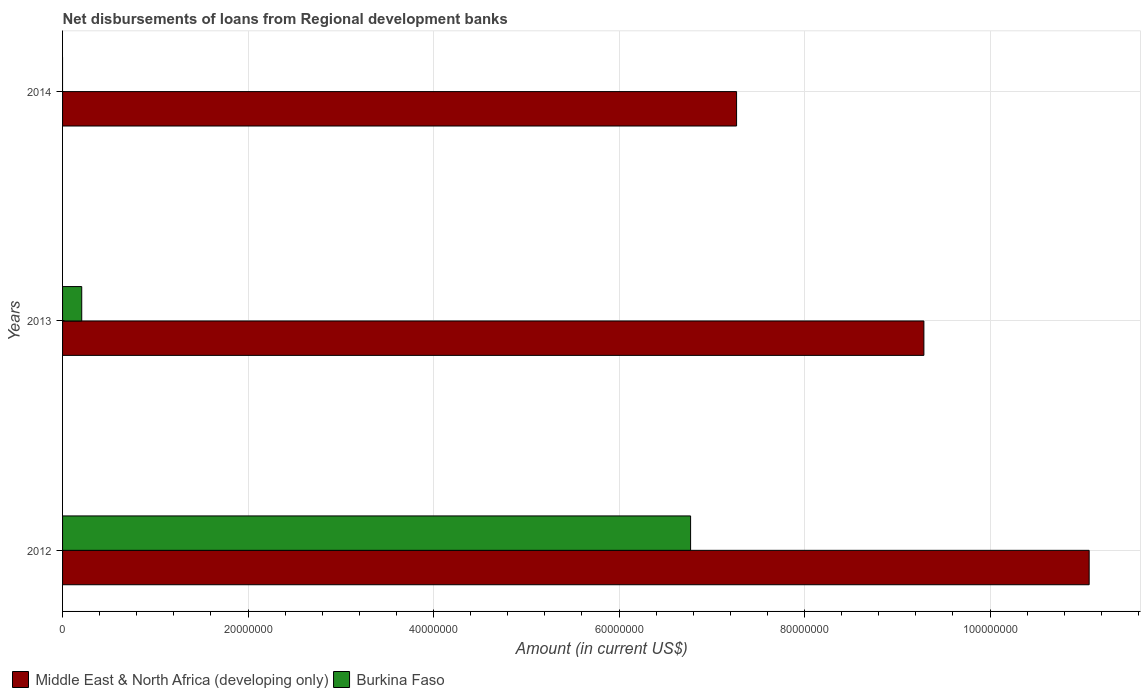How many different coloured bars are there?
Your response must be concise. 2. Are the number of bars per tick equal to the number of legend labels?
Keep it short and to the point. No. Are the number of bars on each tick of the Y-axis equal?
Ensure brevity in your answer.  No. How many bars are there on the 3rd tick from the top?
Offer a terse response. 2. How many bars are there on the 1st tick from the bottom?
Your answer should be compact. 2. What is the amount of disbursements of loans from regional development banks in Middle East & North Africa (developing only) in 2012?
Provide a succinct answer. 1.11e+08. Across all years, what is the maximum amount of disbursements of loans from regional development banks in Middle East & North Africa (developing only)?
Give a very brief answer. 1.11e+08. Across all years, what is the minimum amount of disbursements of loans from regional development banks in Middle East & North Africa (developing only)?
Your answer should be very brief. 7.27e+07. In which year was the amount of disbursements of loans from regional development banks in Middle East & North Africa (developing only) maximum?
Your response must be concise. 2012. What is the total amount of disbursements of loans from regional development banks in Burkina Faso in the graph?
Keep it short and to the point. 6.98e+07. What is the difference between the amount of disbursements of loans from regional development banks in Burkina Faso in 2012 and that in 2013?
Ensure brevity in your answer.  6.56e+07. What is the difference between the amount of disbursements of loans from regional development banks in Middle East & North Africa (developing only) in 2014 and the amount of disbursements of loans from regional development banks in Burkina Faso in 2012?
Make the answer very short. 4.96e+06. What is the average amount of disbursements of loans from regional development banks in Burkina Faso per year?
Make the answer very short. 2.33e+07. In the year 2012, what is the difference between the amount of disbursements of loans from regional development banks in Middle East & North Africa (developing only) and amount of disbursements of loans from regional development banks in Burkina Faso?
Offer a very short reply. 4.30e+07. In how many years, is the amount of disbursements of loans from regional development banks in Middle East & North Africa (developing only) greater than 56000000 US$?
Offer a terse response. 3. What is the ratio of the amount of disbursements of loans from regional development banks in Middle East & North Africa (developing only) in 2013 to that in 2014?
Keep it short and to the point. 1.28. Is the difference between the amount of disbursements of loans from regional development banks in Middle East & North Africa (developing only) in 2012 and 2013 greater than the difference between the amount of disbursements of loans from regional development banks in Burkina Faso in 2012 and 2013?
Make the answer very short. No. What is the difference between the highest and the second highest amount of disbursements of loans from regional development banks in Middle East & North Africa (developing only)?
Make the answer very short. 1.78e+07. What is the difference between the highest and the lowest amount of disbursements of loans from regional development banks in Middle East & North Africa (developing only)?
Keep it short and to the point. 3.80e+07. Are all the bars in the graph horizontal?
Provide a succinct answer. Yes. How many years are there in the graph?
Your answer should be compact. 3. What is the difference between two consecutive major ticks on the X-axis?
Provide a succinct answer. 2.00e+07. Are the values on the major ticks of X-axis written in scientific E-notation?
Offer a terse response. No. Does the graph contain any zero values?
Offer a terse response. Yes. Where does the legend appear in the graph?
Keep it short and to the point. Bottom left. What is the title of the graph?
Your response must be concise. Net disbursements of loans from Regional development banks. Does "Togo" appear as one of the legend labels in the graph?
Offer a very short reply. No. What is the label or title of the X-axis?
Ensure brevity in your answer.  Amount (in current US$). What is the Amount (in current US$) of Middle East & North Africa (developing only) in 2012?
Provide a short and direct response. 1.11e+08. What is the Amount (in current US$) in Burkina Faso in 2012?
Provide a short and direct response. 6.77e+07. What is the Amount (in current US$) in Middle East & North Africa (developing only) in 2013?
Keep it short and to the point. 9.29e+07. What is the Amount (in current US$) of Burkina Faso in 2013?
Your answer should be very brief. 2.07e+06. What is the Amount (in current US$) in Middle East & North Africa (developing only) in 2014?
Provide a short and direct response. 7.27e+07. Across all years, what is the maximum Amount (in current US$) in Middle East & North Africa (developing only)?
Offer a very short reply. 1.11e+08. Across all years, what is the maximum Amount (in current US$) of Burkina Faso?
Ensure brevity in your answer.  6.77e+07. Across all years, what is the minimum Amount (in current US$) of Middle East & North Africa (developing only)?
Keep it short and to the point. 7.27e+07. What is the total Amount (in current US$) of Middle East & North Africa (developing only) in the graph?
Give a very brief answer. 2.76e+08. What is the total Amount (in current US$) of Burkina Faso in the graph?
Your answer should be very brief. 6.98e+07. What is the difference between the Amount (in current US$) in Middle East & North Africa (developing only) in 2012 and that in 2013?
Your answer should be very brief. 1.78e+07. What is the difference between the Amount (in current US$) of Burkina Faso in 2012 and that in 2013?
Your response must be concise. 6.56e+07. What is the difference between the Amount (in current US$) in Middle East & North Africa (developing only) in 2012 and that in 2014?
Your response must be concise. 3.80e+07. What is the difference between the Amount (in current US$) of Middle East & North Africa (developing only) in 2013 and that in 2014?
Your answer should be compact. 2.02e+07. What is the difference between the Amount (in current US$) of Middle East & North Africa (developing only) in 2012 and the Amount (in current US$) of Burkina Faso in 2013?
Keep it short and to the point. 1.09e+08. What is the average Amount (in current US$) of Middle East & North Africa (developing only) per year?
Give a very brief answer. 9.21e+07. What is the average Amount (in current US$) in Burkina Faso per year?
Provide a succinct answer. 2.33e+07. In the year 2012, what is the difference between the Amount (in current US$) of Middle East & North Africa (developing only) and Amount (in current US$) of Burkina Faso?
Offer a terse response. 4.30e+07. In the year 2013, what is the difference between the Amount (in current US$) in Middle East & North Africa (developing only) and Amount (in current US$) in Burkina Faso?
Your answer should be very brief. 9.08e+07. What is the ratio of the Amount (in current US$) in Middle East & North Africa (developing only) in 2012 to that in 2013?
Give a very brief answer. 1.19. What is the ratio of the Amount (in current US$) of Burkina Faso in 2012 to that in 2013?
Your answer should be compact. 32.76. What is the ratio of the Amount (in current US$) of Middle East & North Africa (developing only) in 2012 to that in 2014?
Provide a short and direct response. 1.52. What is the ratio of the Amount (in current US$) in Middle East & North Africa (developing only) in 2013 to that in 2014?
Your answer should be compact. 1.28. What is the difference between the highest and the second highest Amount (in current US$) of Middle East & North Africa (developing only)?
Offer a very short reply. 1.78e+07. What is the difference between the highest and the lowest Amount (in current US$) of Middle East & North Africa (developing only)?
Offer a terse response. 3.80e+07. What is the difference between the highest and the lowest Amount (in current US$) of Burkina Faso?
Your answer should be very brief. 6.77e+07. 